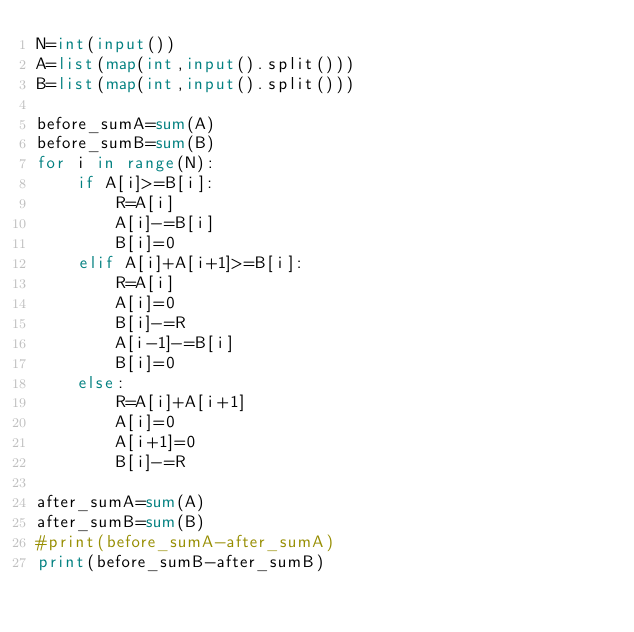Convert code to text. <code><loc_0><loc_0><loc_500><loc_500><_Python_>N=int(input())
A=list(map(int,input().split()))
B=list(map(int,input().split()))

before_sumA=sum(A)
before_sumB=sum(B)
for i in range(N):
    if A[i]>=B[i]:
        R=A[i]
        A[i]-=B[i]
        B[i]=0
    elif A[i]+A[i+1]>=B[i]:
        R=A[i]
        A[i]=0
        B[i]-=R
        A[i-1]-=B[i]
        B[i]=0
    else:
        R=A[i]+A[i+1]
        A[i]=0
        A[i+1]=0
        B[i]-=R

after_sumA=sum(A)
after_sumB=sum(B)
#print(before_sumA-after_sumA)
print(before_sumB-after_sumB)
</code> 